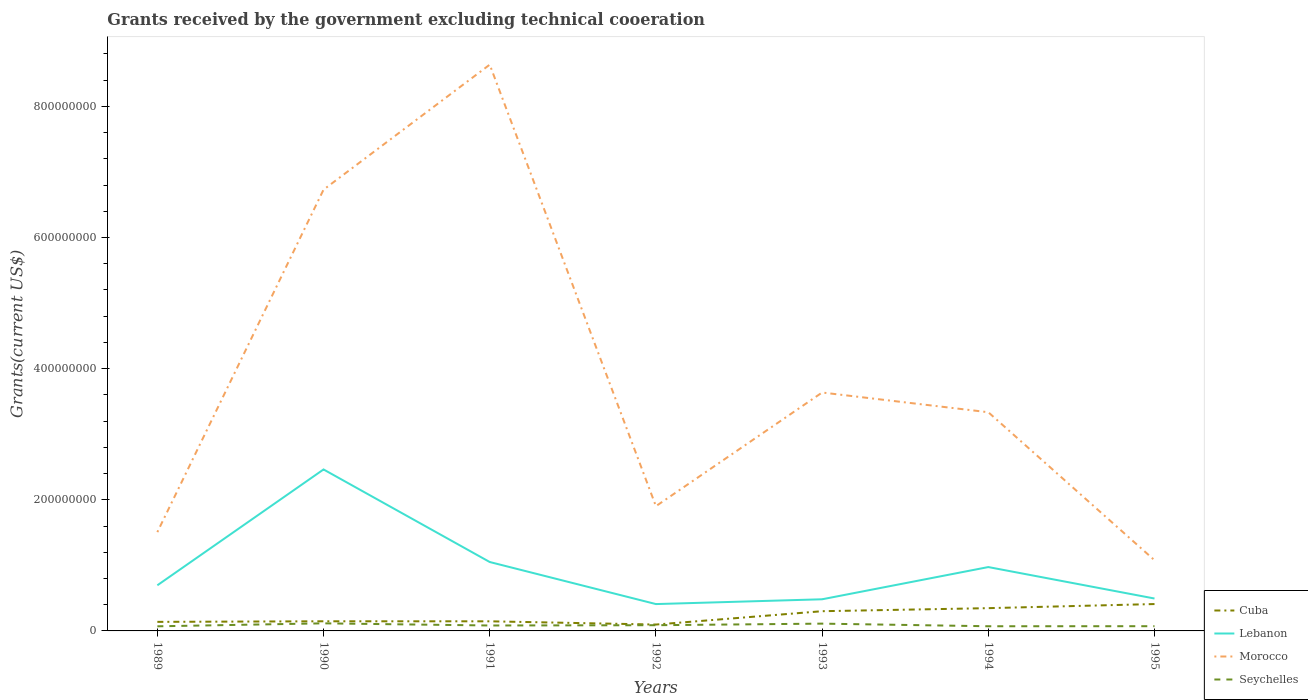Across all years, what is the maximum total grants received by the government in Cuba?
Make the answer very short. 9.71e+06. In which year was the total grants received by the government in Morocco maximum?
Give a very brief answer. 1995. What is the total total grants received by the government in Cuba in the graph?
Your answer should be very brief. -9.00e+05. What is the difference between the highest and the second highest total grants received by the government in Morocco?
Your response must be concise. 7.56e+08. Is the total grants received by the government in Lebanon strictly greater than the total grants received by the government in Seychelles over the years?
Make the answer very short. No. How many lines are there?
Ensure brevity in your answer.  4. How many years are there in the graph?
Your response must be concise. 7. What is the difference between two consecutive major ticks on the Y-axis?
Offer a very short reply. 2.00e+08. Does the graph contain any zero values?
Your answer should be very brief. No. Does the graph contain grids?
Offer a terse response. No. Where does the legend appear in the graph?
Your response must be concise. Bottom right. How many legend labels are there?
Offer a terse response. 4. How are the legend labels stacked?
Make the answer very short. Vertical. What is the title of the graph?
Offer a terse response. Grants received by the government excluding technical cooeration. Does "Uzbekistan" appear as one of the legend labels in the graph?
Ensure brevity in your answer.  No. What is the label or title of the Y-axis?
Your answer should be very brief. Grants(current US$). What is the Grants(current US$) of Cuba in 1989?
Provide a succinct answer. 1.38e+07. What is the Grants(current US$) of Lebanon in 1989?
Ensure brevity in your answer.  6.96e+07. What is the Grants(current US$) of Morocco in 1989?
Your response must be concise. 1.51e+08. What is the Grants(current US$) of Seychelles in 1989?
Provide a short and direct response. 7.04e+06. What is the Grants(current US$) in Cuba in 1990?
Your response must be concise. 1.47e+07. What is the Grants(current US$) in Lebanon in 1990?
Provide a short and direct response. 2.46e+08. What is the Grants(current US$) of Morocco in 1990?
Give a very brief answer. 6.73e+08. What is the Grants(current US$) of Seychelles in 1990?
Your answer should be compact. 1.16e+07. What is the Grants(current US$) in Cuba in 1991?
Your response must be concise. 1.47e+07. What is the Grants(current US$) of Lebanon in 1991?
Your answer should be very brief. 1.05e+08. What is the Grants(current US$) in Morocco in 1991?
Keep it short and to the point. 8.64e+08. What is the Grants(current US$) of Seychelles in 1991?
Offer a very short reply. 8.28e+06. What is the Grants(current US$) in Cuba in 1992?
Make the answer very short. 9.71e+06. What is the Grants(current US$) in Lebanon in 1992?
Provide a succinct answer. 4.09e+07. What is the Grants(current US$) in Morocco in 1992?
Keep it short and to the point. 1.90e+08. What is the Grants(current US$) of Seychelles in 1992?
Provide a short and direct response. 8.72e+06. What is the Grants(current US$) in Cuba in 1993?
Offer a very short reply. 3.01e+07. What is the Grants(current US$) in Lebanon in 1993?
Your answer should be very brief. 4.82e+07. What is the Grants(current US$) in Morocco in 1993?
Make the answer very short. 3.64e+08. What is the Grants(current US$) of Seychelles in 1993?
Provide a short and direct response. 1.11e+07. What is the Grants(current US$) in Cuba in 1994?
Offer a very short reply. 3.47e+07. What is the Grants(current US$) in Lebanon in 1994?
Provide a succinct answer. 9.74e+07. What is the Grants(current US$) of Morocco in 1994?
Give a very brief answer. 3.34e+08. What is the Grants(current US$) of Seychelles in 1994?
Offer a very short reply. 7.12e+06. What is the Grants(current US$) of Cuba in 1995?
Provide a succinct answer. 4.10e+07. What is the Grants(current US$) of Lebanon in 1995?
Make the answer very short. 4.94e+07. What is the Grants(current US$) in Morocco in 1995?
Offer a very short reply. 1.08e+08. What is the Grants(current US$) in Seychelles in 1995?
Offer a terse response. 7.20e+06. Across all years, what is the maximum Grants(current US$) in Cuba?
Your answer should be very brief. 4.10e+07. Across all years, what is the maximum Grants(current US$) of Lebanon?
Provide a short and direct response. 2.46e+08. Across all years, what is the maximum Grants(current US$) of Morocco?
Offer a very short reply. 8.64e+08. Across all years, what is the maximum Grants(current US$) of Seychelles?
Keep it short and to the point. 1.16e+07. Across all years, what is the minimum Grants(current US$) of Cuba?
Provide a succinct answer. 9.71e+06. Across all years, what is the minimum Grants(current US$) in Lebanon?
Your answer should be very brief. 4.09e+07. Across all years, what is the minimum Grants(current US$) of Morocco?
Offer a very short reply. 1.08e+08. Across all years, what is the minimum Grants(current US$) in Seychelles?
Provide a short and direct response. 7.04e+06. What is the total Grants(current US$) of Cuba in the graph?
Offer a very short reply. 1.59e+08. What is the total Grants(current US$) of Lebanon in the graph?
Your answer should be compact. 6.57e+08. What is the total Grants(current US$) in Morocco in the graph?
Make the answer very short. 2.68e+09. What is the total Grants(current US$) in Seychelles in the graph?
Make the answer very short. 6.11e+07. What is the difference between the Grants(current US$) in Cuba in 1989 and that in 1990?
Offer a very short reply. -9.00e+05. What is the difference between the Grants(current US$) of Lebanon in 1989 and that in 1990?
Keep it short and to the point. -1.77e+08. What is the difference between the Grants(current US$) in Morocco in 1989 and that in 1990?
Your response must be concise. -5.22e+08. What is the difference between the Grants(current US$) of Seychelles in 1989 and that in 1990?
Give a very brief answer. -4.54e+06. What is the difference between the Grants(current US$) of Cuba in 1989 and that in 1991?
Make the answer very short. -8.50e+05. What is the difference between the Grants(current US$) of Lebanon in 1989 and that in 1991?
Ensure brevity in your answer.  -3.55e+07. What is the difference between the Grants(current US$) in Morocco in 1989 and that in 1991?
Give a very brief answer. -7.13e+08. What is the difference between the Grants(current US$) of Seychelles in 1989 and that in 1991?
Your answer should be very brief. -1.24e+06. What is the difference between the Grants(current US$) in Cuba in 1989 and that in 1992?
Your response must be concise. 4.10e+06. What is the difference between the Grants(current US$) in Lebanon in 1989 and that in 1992?
Make the answer very short. 2.87e+07. What is the difference between the Grants(current US$) of Morocco in 1989 and that in 1992?
Offer a very short reply. -3.96e+07. What is the difference between the Grants(current US$) of Seychelles in 1989 and that in 1992?
Offer a terse response. -1.68e+06. What is the difference between the Grants(current US$) in Cuba in 1989 and that in 1993?
Provide a succinct answer. -1.63e+07. What is the difference between the Grants(current US$) in Lebanon in 1989 and that in 1993?
Give a very brief answer. 2.14e+07. What is the difference between the Grants(current US$) in Morocco in 1989 and that in 1993?
Make the answer very short. -2.13e+08. What is the difference between the Grants(current US$) of Seychelles in 1989 and that in 1993?
Offer a very short reply. -4.08e+06. What is the difference between the Grants(current US$) of Cuba in 1989 and that in 1994?
Ensure brevity in your answer.  -2.09e+07. What is the difference between the Grants(current US$) in Lebanon in 1989 and that in 1994?
Offer a terse response. -2.78e+07. What is the difference between the Grants(current US$) of Morocco in 1989 and that in 1994?
Ensure brevity in your answer.  -1.83e+08. What is the difference between the Grants(current US$) of Seychelles in 1989 and that in 1994?
Make the answer very short. -8.00e+04. What is the difference between the Grants(current US$) of Cuba in 1989 and that in 1995?
Your response must be concise. -2.72e+07. What is the difference between the Grants(current US$) of Lebanon in 1989 and that in 1995?
Your response must be concise. 2.02e+07. What is the difference between the Grants(current US$) in Morocco in 1989 and that in 1995?
Ensure brevity in your answer.  4.28e+07. What is the difference between the Grants(current US$) in Lebanon in 1990 and that in 1991?
Offer a very short reply. 1.41e+08. What is the difference between the Grants(current US$) in Morocco in 1990 and that in 1991?
Provide a succinct answer. -1.91e+08. What is the difference between the Grants(current US$) in Seychelles in 1990 and that in 1991?
Your answer should be compact. 3.30e+06. What is the difference between the Grants(current US$) of Lebanon in 1990 and that in 1992?
Give a very brief answer. 2.05e+08. What is the difference between the Grants(current US$) in Morocco in 1990 and that in 1992?
Offer a very short reply. 4.83e+08. What is the difference between the Grants(current US$) in Seychelles in 1990 and that in 1992?
Provide a short and direct response. 2.86e+06. What is the difference between the Grants(current US$) in Cuba in 1990 and that in 1993?
Your response must be concise. -1.54e+07. What is the difference between the Grants(current US$) in Lebanon in 1990 and that in 1993?
Offer a terse response. 1.98e+08. What is the difference between the Grants(current US$) of Morocco in 1990 and that in 1993?
Keep it short and to the point. 3.09e+08. What is the difference between the Grants(current US$) in Seychelles in 1990 and that in 1993?
Make the answer very short. 4.60e+05. What is the difference between the Grants(current US$) of Cuba in 1990 and that in 1994?
Provide a short and direct response. -2.00e+07. What is the difference between the Grants(current US$) in Lebanon in 1990 and that in 1994?
Make the answer very short. 1.49e+08. What is the difference between the Grants(current US$) in Morocco in 1990 and that in 1994?
Offer a very short reply. 3.39e+08. What is the difference between the Grants(current US$) in Seychelles in 1990 and that in 1994?
Make the answer very short. 4.46e+06. What is the difference between the Grants(current US$) of Cuba in 1990 and that in 1995?
Make the answer very short. -2.63e+07. What is the difference between the Grants(current US$) in Lebanon in 1990 and that in 1995?
Your response must be concise. 1.97e+08. What is the difference between the Grants(current US$) in Morocco in 1990 and that in 1995?
Provide a short and direct response. 5.65e+08. What is the difference between the Grants(current US$) in Seychelles in 1990 and that in 1995?
Ensure brevity in your answer.  4.38e+06. What is the difference between the Grants(current US$) of Cuba in 1991 and that in 1992?
Keep it short and to the point. 4.95e+06. What is the difference between the Grants(current US$) in Lebanon in 1991 and that in 1992?
Your answer should be very brief. 6.42e+07. What is the difference between the Grants(current US$) in Morocco in 1991 and that in 1992?
Your answer should be compact. 6.73e+08. What is the difference between the Grants(current US$) of Seychelles in 1991 and that in 1992?
Offer a terse response. -4.40e+05. What is the difference between the Grants(current US$) in Cuba in 1991 and that in 1993?
Give a very brief answer. -1.54e+07. What is the difference between the Grants(current US$) in Lebanon in 1991 and that in 1993?
Your answer should be very brief. 5.68e+07. What is the difference between the Grants(current US$) of Morocco in 1991 and that in 1993?
Provide a succinct answer. 5.00e+08. What is the difference between the Grants(current US$) of Seychelles in 1991 and that in 1993?
Make the answer very short. -2.84e+06. What is the difference between the Grants(current US$) of Cuba in 1991 and that in 1994?
Provide a succinct answer. -2.01e+07. What is the difference between the Grants(current US$) in Lebanon in 1991 and that in 1994?
Keep it short and to the point. 7.70e+06. What is the difference between the Grants(current US$) in Morocco in 1991 and that in 1994?
Keep it short and to the point. 5.30e+08. What is the difference between the Grants(current US$) of Seychelles in 1991 and that in 1994?
Keep it short and to the point. 1.16e+06. What is the difference between the Grants(current US$) in Cuba in 1991 and that in 1995?
Provide a succinct answer. -2.63e+07. What is the difference between the Grants(current US$) in Lebanon in 1991 and that in 1995?
Your answer should be very brief. 5.57e+07. What is the difference between the Grants(current US$) of Morocco in 1991 and that in 1995?
Your answer should be compact. 7.56e+08. What is the difference between the Grants(current US$) of Seychelles in 1991 and that in 1995?
Make the answer very short. 1.08e+06. What is the difference between the Grants(current US$) in Cuba in 1992 and that in 1993?
Provide a short and direct response. -2.04e+07. What is the difference between the Grants(current US$) of Lebanon in 1992 and that in 1993?
Keep it short and to the point. -7.31e+06. What is the difference between the Grants(current US$) of Morocco in 1992 and that in 1993?
Provide a short and direct response. -1.73e+08. What is the difference between the Grants(current US$) of Seychelles in 1992 and that in 1993?
Keep it short and to the point. -2.40e+06. What is the difference between the Grants(current US$) in Cuba in 1992 and that in 1994?
Keep it short and to the point. -2.50e+07. What is the difference between the Grants(current US$) of Lebanon in 1992 and that in 1994?
Give a very brief answer. -5.64e+07. What is the difference between the Grants(current US$) in Morocco in 1992 and that in 1994?
Make the answer very short. -1.43e+08. What is the difference between the Grants(current US$) in Seychelles in 1992 and that in 1994?
Offer a terse response. 1.60e+06. What is the difference between the Grants(current US$) of Cuba in 1992 and that in 1995?
Your answer should be very brief. -3.13e+07. What is the difference between the Grants(current US$) of Lebanon in 1992 and that in 1995?
Your response must be concise. -8.48e+06. What is the difference between the Grants(current US$) in Morocco in 1992 and that in 1995?
Your answer should be very brief. 8.24e+07. What is the difference between the Grants(current US$) in Seychelles in 1992 and that in 1995?
Provide a short and direct response. 1.52e+06. What is the difference between the Grants(current US$) of Cuba in 1993 and that in 1994?
Make the answer very short. -4.65e+06. What is the difference between the Grants(current US$) in Lebanon in 1993 and that in 1994?
Offer a terse response. -4.91e+07. What is the difference between the Grants(current US$) in Morocco in 1993 and that in 1994?
Keep it short and to the point. 3.01e+07. What is the difference between the Grants(current US$) in Seychelles in 1993 and that in 1994?
Provide a succinct answer. 4.00e+06. What is the difference between the Grants(current US$) in Cuba in 1993 and that in 1995?
Your response must be concise. -1.09e+07. What is the difference between the Grants(current US$) of Lebanon in 1993 and that in 1995?
Offer a terse response. -1.17e+06. What is the difference between the Grants(current US$) of Morocco in 1993 and that in 1995?
Give a very brief answer. 2.56e+08. What is the difference between the Grants(current US$) in Seychelles in 1993 and that in 1995?
Offer a terse response. 3.92e+06. What is the difference between the Grants(current US$) of Cuba in 1994 and that in 1995?
Your response must be concise. -6.27e+06. What is the difference between the Grants(current US$) of Lebanon in 1994 and that in 1995?
Offer a very short reply. 4.80e+07. What is the difference between the Grants(current US$) of Morocco in 1994 and that in 1995?
Make the answer very short. 2.26e+08. What is the difference between the Grants(current US$) of Seychelles in 1994 and that in 1995?
Give a very brief answer. -8.00e+04. What is the difference between the Grants(current US$) of Cuba in 1989 and the Grants(current US$) of Lebanon in 1990?
Make the answer very short. -2.32e+08. What is the difference between the Grants(current US$) of Cuba in 1989 and the Grants(current US$) of Morocco in 1990?
Keep it short and to the point. -6.59e+08. What is the difference between the Grants(current US$) of Cuba in 1989 and the Grants(current US$) of Seychelles in 1990?
Your answer should be very brief. 2.23e+06. What is the difference between the Grants(current US$) in Lebanon in 1989 and the Grants(current US$) in Morocco in 1990?
Provide a succinct answer. -6.03e+08. What is the difference between the Grants(current US$) in Lebanon in 1989 and the Grants(current US$) in Seychelles in 1990?
Offer a very short reply. 5.80e+07. What is the difference between the Grants(current US$) in Morocco in 1989 and the Grants(current US$) in Seychelles in 1990?
Your answer should be very brief. 1.39e+08. What is the difference between the Grants(current US$) of Cuba in 1989 and the Grants(current US$) of Lebanon in 1991?
Provide a succinct answer. -9.13e+07. What is the difference between the Grants(current US$) in Cuba in 1989 and the Grants(current US$) in Morocco in 1991?
Offer a very short reply. -8.50e+08. What is the difference between the Grants(current US$) in Cuba in 1989 and the Grants(current US$) in Seychelles in 1991?
Provide a short and direct response. 5.53e+06. What is the difference between the Grants(current US$) in Lebanon in 1989 and the Grants(current US$) in Morocco in 1991?
Your response must be concise. -7.94e+08. What is the difference between the Grants(current US$) in Lebanon in 1989 and the Grants(current US$) in Seychelles in 1991?
Keep it short and to the point. 6.13e+07. What is the difference between the Grants(current US$) of Morocco in 1989 and the Grants(current US$) of Seychelles in 1991?
Your answer should be very brief. 1.42e+08. What is the difference between the Grants(current US$) of Cuba in 1989 and the Grants(current US$) of Lebanon in 1992?
Offer a terse response. -2.71e+07. What is the difference between the Grants(current US$) of Cuba in 1989 and the Grants(current US$) of Morocco in 1992?
Ensure brevity in your answer.  -1.76e+08. What is the difference between the Grants(current US$) in Cuba in 1989 and the Grants(current US$) in Seychelles in 1992?
Offer a very short reply. 5.09e+06. What is the difference between the Grants(current US$) of Lebanon in 1989 and the Grants(current US$) of Morocco in 1992?
Offer a terse response. -1.21e+08. What is the difference between the Grants(current US$) in Lebanon in 1989 and the Grants(current US$) in Seychelles in 1992?
Provide a short and direct response. 6.09e+07. What is the difference between the Grants(current US$) in Morocco in 1989 and the Grants(current US$) in Seychelles in 1992?
Ensure brevity in your answer.  1.42e+08. What is the difference between the Grants(current US$) in Cuba in 1989 and the Grants(current US$) in Lebanon in 1993?
Keep it short and to the point. -3.44e+07. What is the difference between the Grants(current US$) in Cuba in 1989 and the Grants(current US$) in Morocco in 1993?
Keep it short and to the point. -3.50e+08. What is the difference between the Grants(current US$) in Cuba in 1989 and the Grants(current US$) in Seychelles in 1993?
Give a very brief answer. 2.69e+06. What is the difference between the Grants(current US$) of Lebanon in 1989 and the Grants(current US$) of Morocco in 1993?
Your answer should be compact. -2.94e+08. What is the difference between the Grants(current US$) of Lebanon in 1989 and the Grants(current US$) of Seychelles in 1993?
Your answer should be compact. 5.85e+07. What is the difference between the Grants(current US$) in Morocco in 1989 and the Grants(current US$) in Seychelles in 1993?
Offer a terse response. 1.40e+08. What is the difference between the Grants(current US$) in Cuba in 1989 and the Grants(current US$) in Lebanon in 1994?
Your answer should be very brief. -8.36e+07. What is the difference between the Grants(current US$) in Cuba in 1989 and the Grants(current US$) in Morocco in 1994?
Your answer should be very brief. -3.20e+08. What is the difference between the Grants(current US$) in Cuba in 1989 and the Grants(current US$) in Seychelles in 1994?
Offer a very short reply. 6.69e+06. What is the difference between the Grants(current US$) in Lebanon in 1989 and the Grants(current US$) in Morocco in 1994?
Ensure brevity in your answer.  -2.64e+08. What is the difference between the Grants(current US$) in Lebanon in 1989 and the Grants(current US$) in Seychelles in 1994?
Your answer should be compact. 6.25e+07. What is the difference between the Grants(current US$) of Morocco in 1989 and the Grants(current US$) of Seychelles in 1994?
Provide a short and direct response. 1.44e+08. What is the difference between the Grants(current US$) in Cuba in 1989 and the Grants(current US$) in Lebanon in 1995?
Give a very brief answer. -3.56e+07. What is the difference between the Grants(current US$) of Cuba in 1989 and the Grants(current US$) of Morocco in 1995?
Make the answer very short. -9.40e+07. What is the difference between the Grants(current US$) of Cuba in 1989 and the Grants(current US$) of Seychelles in 1995?
Your answer should be compact. 6.61e+06. What is the difference between the Grants(current US$) of Lebanon in 1989 and the Grants(current US$) of Morocco in 1995?
Keep it short and to the point. -3.83e+07. What is the difference between the Grants(current US$) of Lebanon in 1989 and the Grants(current US$) of Seychelles in 1995?
Provide a succinct answer. 6.24e+07. What is the difference between the Grants(current US$) in Morocco in 1989 and the Grants(current US$) in Seychelles in 1995?
Provide a succinct answer. 1.43e+08. What is the difference between the Grants(current US$) in Cuba in 1990 and the Grants(current US$) in Lebanon in 1991?
Give a very brief answer. -9.04e+07. What is the difference between the Grants(current US$) of Cuba in 1990 and the Grants(current US$) of Morocco in 1991?
Give a very brief answer. -8.49e+08. What is the difference between the Grants(current US$) in Cuba in 1990 and the Grants(current US$) in Seychelles in 1991?
Give a very brief answer. 6.43e+06. What is the difference between the Grants(current US$) of Lebanon in 1990 and the Grants(current US$) of Morocco in 1991?
Ensure brevity in your answer.  -6.17e+08. What is the difference between the Grants(current US$) of Lebanon in 1990 and the Grants(current US$) of Seychelles in 1991?
Your response must be concise. 2.38e+08. What is the difference between the Grants(current US$) in Morocco in 1990 and the Grants(current US$) in Seychelles in 1991?
Your answer should be very brief. 6.65e+08. What is the difference between the Grants(current US$) of Cuba in 1990 and the Grants(current US$) of Lebanon in 1992?
Your answer should be very brief. -2.62e+07. What is the difference between the Grants(current US$) in Cuba in 1990 and the Grants(current US$) in Morocco in 1992?
Provide a succinct answer. -1.76e+08. What is the difference between the Grants(current US$) in Cuba in 1990 and the Grants(current US$) in Seychelles in 1992?
Ensure brevity in your answer.  5.99e+06. What is the difference between the Grants(current US$) of Lebanon in 1990 and the Grants(current US$) of Morocco in 1992?
Your answer should be compact. 5.60e+07. What is the difference between the Grants(current US$) in Lebanon in 1990 and the Grants(current US$) in Seychelles in 1992?
Provide a short and direct response. 2.38e+08. What is the difference between the Grants(current US$) in Morocco in 1990 and the Grants(current US$) in Seychelles in 1992?
Offer a terse response. 6.64e+08. What is the difference between the Grants(current US$) in Cuba in 1990 and the Grants(current US$) in Lebanon in 1993?
Provide a short and direct response. -3.35e+07. What is the difference between the Grants(current US$) in Cuba in 1990 and the Grants(current US$) in Morocco in 1993?
Give a very brief answer. -3.49e+08. What is the difference between the Grants(current US$) in Cuba in 1990 and the Grants(current US$) in Seychelles in 1993?
Your answer should be compact. 3.59e+06. What is the difference between the Grants(current US$) of Lebanon in 1990 and the Grants(current US$) of Morocco in 1993?
Offer a very short reply. -1.17e+08. What is the difference between the Grants(current US$) in Lebanon in 1990 and the Grants(current US$) in Seychelles in 1993?
Your answer should be compact. 2.35e+08. What is the difference between the Grants(current US$) of Morocco in 1990 and the Grants(current US$) of Seychelles in 1993?
Ensure brevity in your answer.  6.62e+08. What is the difference between the Grants(current US$) of Cuba in 1990 and the Grants(current US$) of Lebanon in 1994?
Provide a succinct answer. -8.27e+07. What is the difference between the Grants(current US$) in Cuba in 1990 and the Grants(current US$) in Morocco in 1994?
Keep it short and to the point. -3.19e+08. What is the difference between the Grants(current US$) in Cuba in 1990 and the Grants(current US$) in Seychelles in 1994?
Provide a short and direct response. 7.59e+06. What is the difference between the Grants(current US$) in Lebanon in 1990 and the Grants(current US$) in Morocco in 1994?
Your answer should be very brief. -8.73e+07. What is the difference between the Grants(current US$) in Lebanon in 1990 and the Grants(current US$) in Seychelles in 1994?
Offer a terse response. 2.39e+08. What is the difference between the Grants(current US$) in Morocco in 1990 and the Grants(current US$) in Seychelles in 1994?
Your response must be concise. 6.66e+08. What is the difference between the Grants(current US$) of Cuba in 1990 and the Grants(current US$) of Lebanon in 1995?
Keep it short and to the point. -3.47e+07. What is the difference between the Grants(current US$) of Cuba in 1990 and the Grants(current US$) of Morocco in 1995?
Offer a very short reply. -9.32e+07. What is the difference between the Grants(current US$) in Cuba in 1990 and the Grants(current US$) in Seychelles in 1995?
Offer a terse response. 7.51e+06. What is the difference between the Grants(current US$) of Lebanon in 1990 and the Grants(current US$) of Morocco in 1995?
Your answer should be very brief. 1.38e+08. What is the difference between the Grants(current US$) in Lebanon in 1990 and the Grants(current US$) in Seychelles in 1995?
Offer a terse response. 2.39e+08. What is the difference between the Grants(current US$) in Morocco in 1990 and the Grants(current US$) in Seychelles in 1995?
Make the answer very short. 6.66e+08. What is the difference between the Grants(current US$) in Cuba in 1991 and the Grants(current US$) in Lebanon in 1992?
Your answer should be very brief. -2.63e+07. What is the difference between the Grants(current US$) of Cuba in 1991 and the Grants(current US$) of Morocco in 1992?
Offer a terse response. -1.76e+08. What is the difference between the Grants(current US$) of Cuba in 1991 and the Grants(current US$) of Seychelles in 1992?
Provide a short and direct response. 5.94e+06. What is the difference between the Grants(current US$) in Lebanon in 1991 and the Grants(current US$) in Morocco in 1992?
Your response must be concise. -8.52e+07. What is the difference between the Grants(current US$) of Lebanon in 1991 and the Grants(current US$) of Seychelles in 1992?
Provide a short and direct response. 9.64e+07. What is the difference between the Grants(current US$) in Morocco in 1991 and the Grants(current US$) in Seychelles in 1992?
Keep it short and to the point. 8.55e+08. What is the difference between the Grants(current US$) of Cuba in 1991 and the Grants(current US$) of Lebanon in 1993?
Your answer should be very brief. -3.36e+07. What is the difference between the Grants(current US$) in Cuba in 1991 and the Grants(current US$) in Morocco in 1993?
Your answer should be compact. -3.49e+08. What is the difference between the Grants(current US$) of Cuba in 1991 and the Grants(current US$) of Seychelles in 1993?
Keep it short and to the point. 3.54e+06. What is the difference between the Grants(current US$) of Lebanon in 1991 and the Grants(current US$) of Morocco in 1993?
Offer a very short reply. -2.59e+08. What is the difference between the Grants(current US$) in Lebanon in 1991 and the Grants(current US$) in Seychelles in 1993?
Your answer should be compact. 9.40e+07. What is the difference between the Grants(current US$) of Morocco in 1991 and the Grants(current US$) of Seychelles in 1993?
Ensure brevity in your answer.  8.53e+08. What is the difference between the Grants(current US$) of Cuba in 1991 and the Grants(current US$) of Lebanon in 1994?
Your answer should be compact. -8.27e+07. What is the difference between the Grants(current US$) in Cuba in 1991 and the Grants(current US$) in Morocco in 1994?
Provide a short and direct response. -3.19e+08. What is the difference between the Grants(current US$) in Cuba in 1991 and the Grants(current US$) in Seychelles in 1994?
Provide a short and direct response. 7.54e+06. What is the difference between the Grants(current US$) of Lebanon in 1991 and the Grants(current US$) of Morocco in 1994?
Your response must be concise. -2.28e+08. What is the difference between the Grants(current US$) of Lebanon in 1991 and the Grants(current US$) of Seychelles in 1994?
Provide a succinct answer. 9.80e+07. What is the difference between the Grants(current US$) of Morocco in 1991 and the Grants(current US$) of Seychelles in 1994?
Give a very brief answer. 8.57e+08. What is the difference between the Grants(current US$) in Cuba in 1991 and the Grants(current US$) in Lebanon in 1995?
Provide a succinct answer. -3.48e+07. What is the difference between the Grants(current US$) of Cuba in 1991 and the Grants(current US$) of Morocco in 1995?
Offer a very short reply. -9.32e+07. What is the difference between the Grants(current US$) in Cuba in 1991 and the Grants(current US$) in Seychelles in 1995?
Offer a very short reply. 7.46e+06. What is the difference between the Grants(current US$) in Lebanon in 1991 and the Grants(current US$) in Morocco in 1995?
Provide a short and direct response. -2.77e+06. What is the difference between the Grants(current US$) in Lebanon in 1991 and the Grants(current US$) in Seychelles in 1995?
Make the answer very short. 9.79e+07. What is the difference between the Grants(current US$) in Morocco in 1991 and the Grants(current US$) in Seychelles in 1995?
Provide a succinct answer. 8.56e+08. What is the difference between the Grants(current US$) of Cuba in 1992 and the Grants(current US$) of Lebanon in 1993?
Your response must be concise. -3.85e+07. What is the difference between the Grants(current US$) of Cuba in 1992 and the Grants(current US$) of Morocco in 1993?
Your answer should be very brief. -3.54e+08. What is the difference between the Grants(current US$) of Cuba in 1992 and the Grants(current US$) of Seychelles in 1993?
Keep it short and to the point. -1.41e+06. What is the difference between the Grants(current US$) in Lebanon in 1992 and the Grants(current US$) in Morocco in 1993?
Provide a succinct answer. -3.23e+08. What is the difference between the Grants(current US$) of Lebanon in 1992 and the Grants(current US$) of Seychelles in 1993?
Your answer should be compact. 2.98e+07. What is the difference between the Grants(current US$) in Morocco in 1992 and the Grants(current US$) in Seychelles in 1993?
Give a very brief answer. 1.79e+08. What is the difference between the Grants(current US$) of Cuba in 1992 and the Grants(current US$) of Lebanon in 1994?
Your answer should be compact. -8.77e+07. What is the difference between the Grants(current US$) of Cuba in 1992 and the Grants(current US$) of Morocco in 1994?
Make the answer very short. -3.24e+08. What is the difference between the Grants(current US$) of Cuba in 1992 and the Grants(current US$) of Seychelles in 1994?
Make the answer very short. 2.59e+06. What is the difference between the Grants(current US$) in Lebanon in 1992 and the Grants(current US$) in Morocco in 1994?
Provide a short and direct response. -2.93e+08. What is the difference between the Grants(current US$) of Lebanon in 1992 and the Grants(current US$) of Seychelles in 1994?
Provide a succinct answer. 3.38e+07. What is the difference between the Grants(current US$) of Morocco in 1992 and the Grants(current US$) of Seychelles in 1994?
Your answer should be compact. 1.83e+08. What is the difference between the Grants(current US$) in Cuba in 1992 and the Grants(current US$) in Lebanon in 1995?
Offer a terse response. -3.97e+07. What is the difference between the Grants(current US$) of Cuba in 1992 and the Grants(current US$) of Morocco in 1995?
Offer a very short reply. -9.82e+07. What is the difference between the Grants(current US$) of Cuba in 1992 and the Grants(current US$) of Seychelles in 1995?
Make the answer very short. 2.51e+06. What is the difference between the Grants(current US$) of Lebanon in 1992 and the Grants(current US$) of Morocco in 1995?
Make the answer very short. -6.69e+07. What is the difference between the Grants(current US$) of Lebanon in 1992 and the Grants(current US$) of Seychelles in 1995?
Provide a succinct answer. 3.37e+07. What is the difference between the Grants(current US$) in Morocco in 1992 and the Grants(current US$) in Seychelles in 1995?
Offer a terse response. 1.83e+08. What is the difference between the Grants(current US$) in Cuba in 1993 and the Grants(current US$) in Lebanon in 1994?
Offer a terse response. -6.73e+07. What is the difference between the Grants(current US$) in Cuba in 1993 and the Grants(current US$) in Morocco in 1994?
Make the answer very short. -3.03e+08. What is the difference between the Grants(current US$) in Cuba in 1993 and the Grants(current US$) in Seychelles in 1994?
Make the answer very short. 2.30e+07. What is the difference between the Grants(current US$) in Lebanon in 1993 and the Grants(current US$) in Morocco in 1994?
Give a very brief answer. -2.85e+08. What is the difference between the Grants(current US$) in Lebanon in 1993 and the Grants(current US$) in Seychelles in 1994?
Make the answer very short. 4.11e+07. What is the difference between the Grants(current US$) in Morocco in 1993 and the Grants(current US$) in Seychelles in 1994?
Ensure brevity in your answer.  3.56e+08. What is the difference between the Grants(current US$) of Cuba in 1993 and the Grants(current US$) of Lebanon in 1995?
Offer a very short reply. -1.94e+07. What is the difference between the Grants(current US$) of Cuba in 1993 and the Grants(current US$) of Morocco in 1995?
Your response must be concise. -7.78e+07. What is the difference between the Grants(current US$) in Cuba in 1993 and the Grants(current US$) in Seychelles in 1995?
Offer a terse response. 2.29e+07. What is the difference between the Grants(current US$) in Lebanon in 1993 and the Grants(current US$) in Morocco in 1995?
Give a very brief answer. -5.96e+07. What is the difference between the Grants(current US$) of Lebanon in 1993 and the Grants(current US$) of Seychelles in 1995?
Make the answer very short. 4.10e+07. What is the difference between the Grants(current US$) of Morocco in 1993 and the Grants(current US$) of Seychelles in 1995?
Offer a terse response. 3.56e+08. What is the difference between the Grants(current US$) of Cuba in 1994 and the Grants(current US$) of Lebanon in 1995?
Keep it short and to the point. -1.47e+07. What is the difference between the Grants(current US$) of Cuba in 1994 and the Grants(current US$) of Morocco in 1995?
Your answer should be very brief. -7.31e+07. What is the difference between the Grants(current US$) of Cuba in 1994 and the Grants(current US$) of Seychelles in 1995?
Provide a succinct answer. 2.75e+07. What is the difference between the Grants(current US$) in Lebanon in 1994 and the Grants(current US$) in Morocco in 1995?
Your answer should be very brief. -1.05e+07. What is the difference between the Grants(current US$) in Lebanon in 1994 and the Grants(current US$) in Seychelles in 1995?
Provide a short and direct response. 9.02e+07. What is the difference between the Grants(current US$) of Morocco in 1994 and the Grants(current US$) of Seychelles in 1995?
Offer a very short reply. 3.26e+08. What is the average Grants(current US$) of Cuba per year?
Ensure brevity in your answer.  2.27e+07. What is the average Grants(current US$) in Lebanon per year?
Ensure brevity in your answer.  9.39e+07. What is the average Grants(current US$) of Morocco per year?
Keep it short and to the point. 3.83e+08. What is the average Grants(current US$) of Seychelles per year?
Your answer should be compact. 8.72e+06. In the year 1989, what is the difference between the Grants(current US$) of Cuba and Grants(current US$) of Lebanon?
Provide a succinct answer. -5.58e+07. In the year 1989, what is the difference between the Grants(current US$) of Cuba and Grants(current US$) of Morocco?
Give a very brief answer. -1.37e+08. In the year 1989, what is the difference between the Grants(current US$) of Cuba and Grants(current US$) of Seychelles?
Your answer should be very brief. 6.77e+06. In the year 1989, what is the difference between the Grants(current US$) in Lebanon and Grants(current US$) in Morocco?
Your answer should be compact. -8.11e+07. In the year 1989, what is the difference between the Grants(current US$) in Lebanon and Grants(current US$) in Seychelles?
Ensure brevity in your answer.  6.26e+07. In the year 1989, what is the difference between the Grants(current US$) in Morocco and Grants(current US$) in Seychelles?
Your answer should be compact. 1.44e+08. In the year 1990, what is the difference between the Grants(current US$) of Cuba and Grants(current US$) of Lebanon?
Keep it short and to the point. -2.32e+08. In the year 1990, what is the difference between the Grants(current US$) in Cuba and Grants(current US$) in Morocco?
Offer a terse response. -6.58e+08. In the year 1990, what is the difference between the Grants(current US$) in Cuba and Grants(current US$) in Seychelles?
Make the answer very short. 3.13e+06. In the year 1990, what is the difference between the Grants(current US$) in Lebanon and Grants(current US$) in Morocco?
Provide a succinct answer. -4.27e+08. In the year 1990, what is the difference between the Grants(current US$) in Lebanon and Grants(current US$) in Seychelles?
Ensure brevity in your answer.  2.35e+08. In the year 1990, what is the difference between the Grants(current US$) in Morocco and Grants(current US$) in Seychelles?
Offer a very short reply. 6.61e+08. In the year 1991, what is the difference between the Grants(current US$) in Cuba and Grants(current US$) in Lebanon?
Your answer should be very brief. -9.04e+07. In the year 1991, what is the difference between the Grants(current US$) of Cuba and Grants(current US$) of Morocco?
Your answer should be compact. -8.49e+08. In the year 1991, what is the difference between the Grants(current US$) of Cuba and Grants(current US$) of Seychelles?
Provide a succinct answer. 6.38e+06. In the year 1991, what is the difference between the Grants(current US$) in Lebanon and Grants(current US$) in Morocco?
Offer a terse response. -7.59e+08. In the year 1991, what is the difference between the Grants(current US$) of Lebanon and Grants(current US$) of Seychelles?
Your response must be concise. 9.68e+07. In the year 1991, what is the difference between the Grants(current US$) in Morocco and Grants(current US$) in Seychelles?
Offer a very short reply. 8.55e+08. In the year 1992, what is the difference between the Grants(current US$) in Cuba and Grants(current US$) in Lebanon?
Your answer should be compact. -3.12e+07. In the year 1992, what is the difference between the Grants(current US$) in Cuba and Grants(current US$) in Morocco?
Ensure brevity in your answer.  -1.81e+08. In the year 1992, what is the difference between the Grants(current US$) in Cuba and Grants(current US$) in Seychelles?
Make the answer very short. 9.90e+05. In the year 1992, what is the difference between the Grants(current US$) of Lebanon and Grants(current US$) of Morocco?
Ensure brevity in your answer.  -1.49e+08. In the year 1992, what is the difference between the Grants(current US$) in Lebanon and Grants(current US$) in Seychelles?
Offer a terse response. 3.22e+07. In the year 1992, what is the difference between the Grants(current US$) of Morocco and Grants(current US$) of Seychelles?
Offer a very short reply. 1.82e+08. In the year 1993, what is the difference between the Grants(current US$) of Cuba and Grants(current US$) of Lebanon?
Provide a succinct answer. -1.82e+07. In the year 1993, what is the difference between the Grants(current US$) in Cuba and Grants(current US$) in Morocco?
Give a very brief answer. -3.34e+08. In the year 1993, what is the difference between the Grants(current US$) of Cuba and Grants(current US$) of Seychelles?
Provide a succinct answer. 1.90e+07. In the year 1993, what is the difference between the Grants(current US$) in Lebanon and Grants(current US$) in Morocco?
Your answer should be very brief. -3.15e+08. In the year 1993, what is the difference between the Grants(current US$) of Lebanon and Grants(current US$) of Seychelles?
Provide a short and direct response. 3.71e+07. In the year 1993, what is the difference between the Grants(current US$) in Morocco and Grants(current US$) in Seychelles?
Your answer should be compact. 3.52e+08. In the year 1994, what is the difference between the Grants(current US$) in Cuba and Grants(current US$) in Lebanon?
Your answer should be very brief. -6.27e+07. In the year 1994, what is the difference between the Grants(current US$) in Cuba and Grants(current US$) in Morocco?
Offer a very short reply. -2.99e+08. In the year 1994, what is the difference between the Grants(current US$) of Cuba and Grants(current US$) of Seychelles?
Keep it short and to the point. 2.76e+07. In the year 1994, what is the difference between the Grants(current US$) in Lebanon and Grants(current US$) in Morocco?
Make the answer very short. -2.36e+08. In the year 1994, what is the difference between the Grants(current US$) of Lebanon and Grants(current US$) of Seychelles?
Provide a succinct answer. 9.03e+07. In the year 1994, what is the difference between the Grants(current US$) of Morocco and Grants(current US$) of Seychelles?
Offer a terse response. 3.26e+08. In the year 1995, what is the difference between the Grants(current US$) of Cuba and Grants(current US$) of Lebanon?
Your response must be concise. -8.43e+06. In the year 1995, what is the difference between the Grants(current US$) in Cuba and Grants(current US$) in Morocco?
Offer a terse response. -6.69e+07. In the year 1995, what is the difference between the Grants(current US$) in Cuba and Grants(current US$) in Seychelles?
Provide a short and direct response. 3.38e+07. In the year 1995, what is the difference between the Grants(current US$) in Lebanon and Grants(current US$) in Morocco?
Offer a terse response. -5.84e+07. In the year 1995, what is the difference between the Grants(current US$) in Lebanon and Grants(current US$) in Seychelles?
Offer a terse response. 4.22e+07. In the year 1995, what is the difference between the Grants(current US$) of Morocco and Grants(current US$) of Seychelles?
Offer a very short reply. 1.01e+08. What is the ratio of the Grants(current US$) in Cuba in 1989 to that in 1990?
Provide a succinct answer. 0.94. What is the ratio of the Grants(current US$) of Lebanon in 1989 to that in 1990?
Ensure brevity in your answer.  0.28. What is the ratio of the Grants(current US$) of Morocco in 1989 to that in 1990?
Your answer should be compact. 0.22. What is the ratio of the Grants(current US$) in Seychelles in 1989 to that in 1990?
Give a very brief answer. 0.61. What is the ratio of the Grants(current US$) in Cuba in 1989 to that in 1991?
Offer a very short reply. 0.94. What is the ratio of the Grants(current US$) in Lebanon in 1989 to that in 1991?
Your answer should be very brief. 0.66. What is the ratio of the Grants(current US$) of Morocco in 1989 to that in 1991?
Provide a succinct answer. 0.17. What is the ratio of the Grants(current US$) in Seychelles in 1989 to that in 1991?
Make the answer very short. 0.85. What is the ratio of the Grants(current US$) in Cuba in 1989 to that in 1992?
Your answer should be compact. 1.42. What is the ratio of the Grants(current US$) in Lebanon in 1989 to that in 1992?
Make the answer very short. 1.7. What is the ratio of the Grants(current US$) of Morocco in 1989 to that in 1992?
Your answer should be very brief. 0.79. What is the ratio of the Grants(current US$) in Seychelles in 1989 to that in 1992?
Keep it short and to the point. 0.81. What is the ratio of the Grants(current US$) in Cuba in 1989 to that in 1993?
Provide a short and direct response. 0.46. What is the ratio of the Grants(current US$) of Lebanon in 1989 to that in 1993?
Give a very brief answer. 1.44. What is the ratio of the Grants(current US$) of Morocco in 1989 to that in 1993?
Offer a very short reply. 0.41. What is the ratio of the Grants(current US$) in Seychelles in 1989 to that in 1993?
Make the answer very short. 0.63. What is the ratio of the Grants(current US$) of Cuba in 1989 to that in 1994?
Your answer should be compact. 0.4. What is the ratio of the Grants(current US$) in Lebanon in 1989 to that in 1994?
Provide a short and direct response. 0.71. What is the ratio of the Grants(current US$) of Morocco in 1989 to that in 1994?
Provide a succinct answer. 0.45. What is the ratio of the Grants(current US$) in Cuba in 1989 to that in 1995?
Give a very brief answer. 0.34. What is the ratio of the Grants(current US$) of Lebanon in 1989 to that in 1995?
Your response must be concise. 1.41. What is the ratio of the Grants(current US$) of Morocco in 1989 to that in 1995?
Offer a very short reply. 1.4. What is the ratio of the Grants(current US$) in Seychelles in 1989 to that in 1995?
Your answer should be compact. 0.98. What is the ratio of the Grants(current US$) of Lebanon in 1990 to that in 1991?
Make the answer very short. 2.34. What is the ratio of the Grants(current US$) of Morocco in 1990 to that in 1991?
Keep it short and to the point. 0.78. What is the ratio of the Grants(current US$) in Seychelles in 1990 to that in 1991?
Make the answer very short. 1.4. What is the ratio of the Grants(current US$) in Cuba in 1990 to that in 1992?
Your answer should be very brief. 1.51. What is the ratio of the Grants(current US$) of Lebanon in 1990 to that in 1992?
Give a very brief answer. 6.02. What is the ratio of the Grants(current US$) of Morocco in 1990 to that in 1992?
Your answer should be compact. 3.54. What is the ratio of the Grants(current US$) in Seychelles in 1990 to that in 1992?
Your answer should be compact. 1.33. What is the ratio of the Grants(current US$) in Cuba in 1990 to that in 1993?
Offer a very short reply. 0.49. What is the ratio of the Grants(current US$) in Lebanon in 1990 to that in 1993?
Ensure brevity in your answer.  5.1. What is the ratio of the Grants(current US$) in Morocco in 1990 to that in 1993?
Your response must be concise. 1.85. What is the ratio of the Grants(current US$) of Seychelles in 1990 to that in 1993?
Offer a terse response. 1.04. What is the ratio of the Grants(current US$) in Cuba in 1990 to that in 1994?
Give a very brief answer. 0.42. What is the ratio of the Grants(current US$) of Lebanon in 1990 to that in 1994?
Provide a succinct answer. 2.53. What is the ratio of the Grants(current US$) in Morocco in 1990 to that in 1994?
Keep it short and to the point. 2.02. What is the ratio of the Grants(current US$) in Seychelles in 1990 to that in 1994?
Your answer should be compact. 1.63. What is the ratio of the Grants(current US$) of Cuba in 1990 to that in 1995?
Provide a short and direct response. 0.36. What is the ratio of the Grants(current US$) in Lebanon in 1990 to that in 1995?
Offer a very short reply. 4.98. What is the ratio of the Grants(current US$) of Morocco in 1990 to that in 1995?
Your answer should be compact. 6.24. What is the ratio of the Grants(current US$) of Seychelles in 1990 to that in 1995?
Your response must be concise. 1.61. What is the ratio of the Grants(current US$) of Cuba in 1991 to that in 1992?
Ensure brevity in your answer.  1.51. What is the ratio of the Grants(current US$) in Lebanon in 1991 to that in 1992?
Keep it short and to the point. 2.57. What is the ratio of the Grants(current US$) in Morocco in 1991 to that in 1992?
Keep it short and to the point. 4.54. What is the ratio of the Grants(current US$) of Seychelles in 1991 to that in 1992?
Your response must be concise. 0.95. What is the ratio of the Grants(current US$) of Cuba in 1991 to that in 1993?
Your answer should be very brief. 0.49. What is the ratio of the Grants(current US$) of Lebanon in 1991 to that in 1993?
Ensure brevity in your answer.  2.18. What is the ratio of the Grants(current US$) in Morocco in 1991 to that in 1993?
Your answer should be very brief. 2.38. What is the ratio of the Grants(current US$) in Seychelles in 1991 to that in 1993?
Offer a very short reply. 0.74. What is the ratio of the Grants(current US$) of Cuba in 1991 to that in 1994?
Your answer should be very brief. 0.42. What is the ratio of the Grants(current US$) in Lebanon in 1991 to that in 1994?
Ensure brevity in your answer.  1.08. What is the ratio of the Grants(current US$) of Morocco in 1991 to that in 1994?
Offer a terse response. 2.59. What is the ratio of the Grants(current US$) in Seychelles in 1991 to that in 1994?
Provide a succinct answer. 1.16. What is the ratio of the Grants(current US$) of Cuba in 1991 to that in 1995?
Offer a terse response. 0.36. What is the ratio of the Grants(current US$) in Lebanon in 1991 to that in 1995?
Provide a succinct answer. 2.13. What is the ratio of the Grants(current US$) in Morocco in 1991 to that in 1995?
Your answer should be very brief. 8.01. What is the ratio of the Grants(current US$) of Seychelles in 1991 to that in 1995?
Your answer should be compact. 1.15. What is the ratio of the Grants(current US$) of Cuba in 1992 to that in 1993?
Provide a short and direct response. 0.32. What is the ratio of the Grants(current US$) of Lebanon in 1992 to that in 1993?
Your response must be concise. 0.85. What is the ratio of the Grants(current US$) of Morocco in 1992 to that in 1993?
Make the answer very short. 0.52. What is the ratio of the Grants(current US$) of Seychelles in 1992 to that in 1993?
Your response must be concise. 0.78. What is the ratio of the Grants(current US$) of Cuba in 1992 to that in 1994?
Your answer should be compact. 0.28. What is the ratio of the Grants(current US$) in Lebanon in 1992 to that in 1994?
Offer a terse response. 0.42. What is the ratio of the Grants(current US$) of Morocco in 1992 to that in 1994?
Provide a short and direct response. 0.57. What is the ratio of the Grants(current US$) of Seychelles in 1992 to that in 1994?
Your answer should be compact. 1.22. What is the ratio of the Grants(current US$) of Cuba in 1992 to that in 1995?
Your response must be concise. 0.24. What is the ratio of the Grants(current US$) in Lebanon in 1992 to that in 1995?
Ensure brevity in your answer.  0.83. What is the ratio of the Grants(current US$) of Morocco in 1992 to that in 1995?
Provide a succinct answer. 1.76. What is the ratio of the Grants(current US$) of Seychelles in 1992 to that in 1995?
Offer a terse response. 1.21. What is the ratio of the Grants(current US$) of Cuba in 1993 to that in 1994?
Keep it short and to the point. 0.87. What is the ratio of the Grants(current US$) in Lebanon in 1993 to that in 1994?
Offer a terse response. 0.5. What is the ratio of the Grants(current US$) in Morocco in 1993 to that in 1994?
Make the answer very short. 1.09. What is the ratio of the Grants(current US$) of Seychelles in 1993 to that in 1994?
Provide a succinct answer. 1.56. What is the ratio of the Grants(current US$) in Cuba in 1993 to that in 1995?
Give a very brief answer. 0.73. What is the ratio of the Grants(current US$) in Lebanon in 1993 to that in 1995?
Your answer should be very brief. 0.98. What is the ratio of the Grants(current US$) in Morocco in 1993 to that in 1995?
Ensure brevity in your answer.  3.37. What is the ratio of the Grants(current US$) of Seychelles in 1993 to that in 1995?
Provide a succinct answer. 1.54. What is the ratio of the Grants(current US$) of Cuba in 1994 to that in 1995?
Keep it short and to the point. 0.85. What is the ratio of the Grants(current US$) of Lebanon in 1994 to that in 1995?
Offer a very short reply. 1.97. What is the ratio of the Grants(current US$) of Morocco in 1994 to that in 1995?
Provide a short and direct response. 3.09. What is the ratio of the Grants(current US$) in Seychelles in 1994 to that in 1995?
Your answer should be compact. 0.99. What is the difference between the highest and the second highest Grants(current US$) of Cuba?
Provide a succinct answer. 6.27e+06. What is the difference between the highest and the second highest Grants(current US$) in Lebanon?
Your response must be concise. 1.41e+08. What is the difference between the highest and the second highest Grants(current US$) of Morocco?
Your answer should be very brief. 1.91e+08. What is the difference between the highest and the second highest Grants(current US$) of Seychelles?
Offer a terse response. 4.60e+05. What is the difference between the highest and the lowest Grants(current US$) of Cuba?
Provide a short and direct response. 3.13e+07. What is the difference between the highest and the lowest Grants(current US$) in Lebanon?
Provide a succinct answer. 2.05e+08. What is the difference between the highest and the lowest Grants(current US$) in Morocco?
Your answer should be very brief. 7.56e+08. What is the difference between the highest and the lowest Grants(current US$) of Seychelles?
Your answer should be very brief. 4.54e+06. 